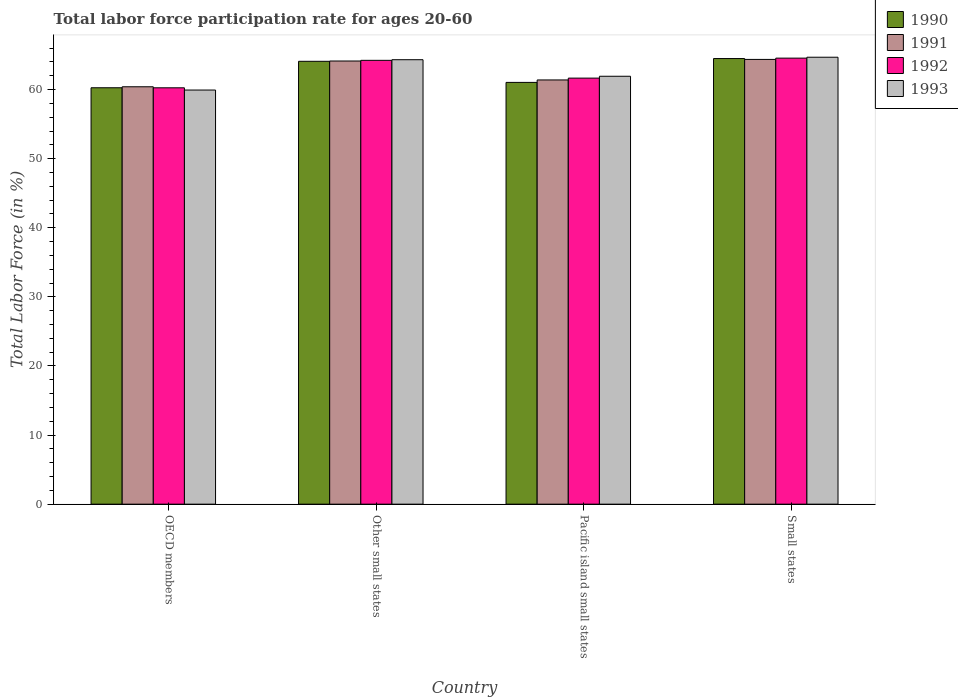How many different coloured bars are there?
Keep it short and to the point. 4. How many groups of bars are there?
Ensure brevity in your answer.  4. How many bars are there on the 4th tick from the left?
Provide a short and direct response. 4. In how many cases, is the number of bars for a given country not equal to the number of legend labels?
Give a very brief answer. 0. What is the labor force participation rate in 1992 in Pacific island small states?
Give a very brief answer. 61.67. Across all countries, what is the maximum labor force participation rate in 1990?
Provide a succinct answer. 64.5. Across all countries, what is the minimum labor force participation rate in 1993?
Make the answer very short. 59.94. In which country was the labor force participation rate in 1992 maximum?
Keep it short and to the point. Small states. What is the total labor force participation rate in 1992 in the graph?
Offer a very short reply. 250.73. What is the difference between the labor force participation rate in 1990 in OECD members and that in Other small states?
Give a very brief answer. -3.83. What is the difference between the labor force participation rate in 1993 in Pacific island small states and the labor force participation rate in 1990 in OECD members?
Make the answer very short. 1.67. What is the average labor force participation rate in 1990 per country?
Your answer should be compact. 62.48. What is the difference between the labor force participation rate of/in 1991 and labor force participation rate of/in 1993 in Small states?
Your answer should be compact. -0.32. In how many countries, is the labor force participation rate in 1990 greater than 64 %?
Give a very brief answer. 2. What is the ratio of the labor force participation rate in 1991 in OECD members to that in Pacific island small states?
Make the answer very short. 0.98. Is the labor force participation rate in 1993 in Other small states less than that in Small states?
Provide a succinct answer. Yes. What is the difference between the highest and the second highest labor force participation rate in 1991?
Offer a very short reply. 0.23. What is the difference between the highest and the lowest labor force participation rate in 1993?
Your answer should be compact. 4.75. In how many countries, is the labor force participation rate in 1990 greater than the average labor force participation rate in 1990 taken over all countries?
Offer a very short reply. 2. Is it the case that in every country, the sum of the labor force participation rate in 1993 and labor force participation rate in 1990 is greater than the sum of labor force participation rate in 1992 and labor force participation rate in 1991?
Offer a very short reply. No. What does the 2nd bar from the left in OECD members represents?
Provide a succinct answer. 1991. What does the 2nd bar from the right in OECD members represents?
Offer a very short reply. 1992. How many countries are there in the graph?
Make the answer very short. 4. What is the difference between two consecutive major ticks on the Y-axis?
Offer a terse response. 10. Does the graph contain any zero values?
Your answer should be compact. No. Where does the legend appear in the graph?
Your response must be concise. Top right. How are the legend labels stacked?
Make the answer very short. Vertical. What is the title of the graph?
Your answer should be compact. Total labor force participation rate for ages 20-60. What is the label or title of the X-axis?
Offer a very short reply. Country. What is the Total Labor Force (in %) of 1990 in OECD members?
Offer a very short reply. 60.27. What is the Total Labor Force (in %) in 1991 in OECD members?
Provide a succinct answer. 60.41. What is the Total Labor Force (in %) of 1992 in OECD members?
Keep it short and to the point. 60.26. What is the Total Labor Force (in %) of 1993 in OECD members?
Give a very brief answer. 59.94. What is the Total Labor Force (in %) of 1990 in Other small states?
Provide a short and direct response. 64.1. What is the Total Labor Force (in %) of 1991 in Other small states?
Provide a short and direct response. 64.14. What is the Total Labor Force (in %) in 1992 in Other small states?
Provide a short and direct response. 64.24. What is the Total Labor Force (in %) in 1993 in Other small states?
Provide a succinct answer. 64.33. What is the Total Labor Force (in %) of 1990 in Pacific island small states?
Offer a terse response. 61.05. What is the Total Labor Force (in %) of 1991 in Pacific island small states?
Your response must be concise. 61.4. What is the Total Labor Force (in %) of 1992 in Pacific island small states?
Offer a very short reply. 61.67. What is the Total Labor Force (in %) of 1993 in Pacific island small states?
Your answer should be compact. 61.94. What is the Total Labor Force (in %) of 1990 in Small states?
Ensure brevity in your answer.  64.5. What is the Total Labor Force (in %) of 1991 in Small states?
Your response must be concise. 64.37. What is the Total Labor Force (in %) of 1992 in Small states?
Ensure brevity in your answer.  64.56. What is the Total Labor Force (in %) in 1993 in Small states?
Offer a very short reply. 64.69. Across all countries, what is the maximum Total Labor Force (in %) in 1990?
Provide a short and direct response. 64.5. Across all countries, what is the maximum Total Labor Force (in %) of 1991?
Offer a terse response. 64.37. Across all countries, what is the maximum Total Labor Force (in %) in 1992?
Offer a very short reply. 64.56. Across all countries, what is the maximum Total Labor Force (in %) in 1993?
Provide a short and direct response. 64.69. Across all countries, what is the minimum Total Labor Force (in %) in 1990?
Offer a very short reply. 60.27. Across all countries, what is the minimum Total Labor Force (in %) in 1991?
Make the answer very short. 60.41. Across all countries, what is the minimum Total Labor Force (in %) in 1992?
Give a very brief answer. 60.26. Across all countries, what is the minimum Total Labor Force (in %) of 1993?
Provide a succinct answer. 59.94. What is the total Total Labor Force (in %) of 1990 in the graph?
Your answer should be very brief. 249.92. What is the total Total Labor Force (in %) in 1991 in the graph?
Your answer should be very brief. 250.33. What is the total Total Labor Force (in %) in 1992 in the graph?
Keep it short and to the point. 250.73. What is the total Total Labor Force (in %) of 1993 in the graph?
Provide a succinct answer. 250.9. What is the difference between the Total Labor Force (in %) in 1990 in OECD members and that in Other small states?
Your answer should be very brief. -3.83. What is the difference between the Total Labor Force (in %) of 1991 in OECD members and that in Other small states?
Make the answer very short. -3.73. What is the difference between the Total Labor Force (in %) in 1992 in OECD members and that in Other small states?
Make the answer very short. -3.98. What is the difference between the Total Labor Force (in %) of 1993 in OECD members and that in Other small states?
Provide a succinct answer. -4.39. What is the difference between the Total Labor Force (in %) of 1990 in OECD members and that in Pacific island small states?
Your response must be concise. -0.78. What is the difference between the Total Labor Force (in %) of 1991 in OECD members and that in Pacific island small states?
Keep it short and to the point. -0.99. What is the difference between the Total Labor Force (in %) of 1992 in OECD members and that in Pacific island small states?
Provide a short and direct response. -1.4. What is the difference between the Total Labor Force (in %) in 1993 in OECD members and that in Pacific island small states?
Keep it short and to the point. -2. What is the difference between the Total Labor Force (in %) of 1990 in OECD members and that in Small states?
Give a very brief answer. -4.23. What is the difference between the Total Labor Force (in %) in 1991 in OECD members and that in Small states?
Your answer should be compact. -3.96. What is the difference between the Total Labor Force (in %) in 1992 in OECD members and that in Small states?
Your response must be concise. -4.3. What is the difference between the Total Labor Force (in %) of 1993 in OECD members and that in Small states?
Offer a terse response. -4.75. What is the difference between the Total Labor Force (in %) in 1990 in Other small states and that in Pacific island small states?
Ensure brevity in your answer.  3.05. What is the difference between the Total Labor Force (in %) of 1991 in Other small states and that in Pacific island small states?
Keep it short and to the point. 2.74. What is the difference between the Total Labor Force (in %) of 1992 in Other small states and that in Pacific island small states?
Keep it short and to the point. 2.57. What is the difference between the Total Labor Force (in %) of 1993 in Other small states and that in Pacific island small states?
Your response must be concise. 2.4. What is the difference between the Total Labor Force (in %) of 1990 in Other small states and that in Small states?
Your answer should be very brief. -0.4. What is the difference between the Total Labor Force (in %) in 1991 in Other small states and that in Small states?
Offer a terse response. -0.23. What is the difference between the Total Labor Force (in %) of 1992 in Other small states and that in Small states?
Provide a short and direct response. -0.32. What is the difference between the Total Labor Force (in %) in 1993 in Other small states and that in Small states?
Ensure brevity in your answer.  -0.36. What is the difference between the Total Labor Force (in %) of 1990 in Pacific island small states and that in Small states?
Ensure brevity in your answer.  -3.45. What is the difference between the Total Labor Force (in %) in 1991 in Pacific island small states and that in Small states?
Provide a short and direct response. -2.97. What is the difference between the Total Labor Force (in %) of 1992 in Pacific island small states and that in Small states?
Give a very brief answer. -2.89. What is the difference between the Total Labor Force (in %) of 1993 in Pacific island small states and that in Small states?
Offer a terse response. -2.75. What is the difference between the Total Labor Force (in %) in 1990 in OECD members and the Total Labor Force (in %) in 1991 in Other small states?
Your response must be concise. -3.87. What is the difference between the Total Labor Force (in %) in 1990 in OECD members and the Total Labor Force (in %) in 1992 in Other small states?
Your response must be concise. -3.97. What is the difference between the Total Labor Force (in %) of 1990 in OECD members and the Total Labor Force (in %) of 1993 in Other small states?
Give a very brief answer. -4.06. What is the difference between the Total Labor Force (in %) in 1991 in OECD members and the Total Labor Force (in %) in 1992 in Other small states?
Offer a very short reply. -3.83. What is the difference between the Total Labor Force (in %) of 1991 in OECD members and the Total Labor Force (in %) of 1993 in Other small states?
Make the answer very short. -3.92. What is the difference between the Total Labor Force (in %) in 1992 in OECD members and the Total Labor Force (in %) in 1993 in Other small states?
Keep it short and to the point. -4.07. What is the difference between the Total Labor Force (in %) of 1990 in OECD members and the Total Labor Force (in %) of 1991 in Pacific island small states?
Offer a terse response. -1.13. What is the difference between the Total Labor Force (in %) in 1990 in OECD members and the Total Labor Force (in %) in 1992 in Pacific island small states?
Ensure brevity in your answer.  -1.4. What is the difference between the Total Labor Force (in %) in 1990 in OECD members and the Total Labor Force (in %) in 1993 in Pacific island small states?
Provide a succinct answer. -1.67. What is the difference between the Total Labor Force (in %) of 1991 in OECD members and the Total Labor Force (in %) of 1992 in Pacific island small states?
Offer a very short reply. -1.25. What is the difference between the Total Labor Force (in %) of 1991 in OECD members and the Total Labor Force (in %) of 1993 in Pacific island small states?
Provide a succinct answer. -1.52. What is the difference between the Total Labor Force (in %) of 1992 in OECD members and the Total Labor Force (in %) of 1993 in Pacific island small states?
Make the answer very short. -1.67. What is the difference between the Total Labor Force (in %) in 1990 in OECD members and the Total Labor Force (in %) in 1991 in Small states?
Your response must be concise. -4.1. What is the difference between the Total Labor Force (in %) in 1990 in OECD members and the Total Labor Force (in %) in 1992 in Small states?
Your answer should be very brief. -4.29. What is the difference between the Total Labor Force (in %) of 1990 in OECD members and the Total Labor Force (in %) of 1993 in Small states?
Ensure brevity in your answer.  -4.42. What is the difference between the Total Labor Force (in %) of 1991 in OECD members and the Total Labor Force (in %) of 1992 in Small states?
Your response must be concise. -4.15. What is the difference between the Total Labor Force (in %) of 1991 in OECD members and the Total Labor Force (in %) of 1993 in Small states?
Offer a very short reply. -4.28. What is the difference between the Total Labor Force (in %) of 1992 in OECD members and the Total Labor Force (in %) of 1993 in Small states?
Offer a very short reply. -4.43. What is the difference between the Total Labor Force (in %) in 1990 in Other small states and the Total Labor Force (in %) in 1991 in Pacific island small states?
Ensure brevity in your answer.  2.7. What is the difference between the Total Labor Force (in %) in 1990 in Other small states and the Total Labor Force (in %) in 1992 in Pacific island small states?
Your answer should be compact. 2.43. What is the difference between the Total Labor Force (in %) in 1990 in Other small states and the Total Labor Force (in %) in 1993 in Pacific island small states?
Make the answer very short. 2.16. What is the difference between the Total Labor Force (in %) of 1991 in Other small states and the Total Labor Force (in %) of 1992 in Pacific island small states?
Your answer should be compact. 2.48. What is the difference between the Total Labor Force (in %) of 1991 in Other small states and the Total Labor Force (in %) of 1993 in Pacific island small states?
Make the answer very short. 2.21. What is the difference between the Total Labor Force (in %) in 1992 in Other small states and the Total Labor Force (in %) in 1993 in Pacific island small states?
Offer a very short reply. 2.3. What is the difference between the Total Labor Force (in %) of 1990 in Other small states and the Total Labor Force (in %) of 1991 in Small states?
Provide a succinct answer. -0.27. What is the difference between the Total Labor Force (in %) in 1990 in Other small states and the Total Labor Force (in %) in 1992 in Small states?
Make the answer very short. -0.46. What is the difference between the Total Labor Force (in %) of 1990 in Other small states and the Total Labor Force (in %) of 1993 in Small states?
Offer a terse response. -0.59. What is the difference between the Total Labor Force (in %) of 1991 in Other small states and the Total Labor Force (in %) of 1992 in Small states?
Your answer should be compact. -0.42. What is the difference between the Total Labor Force (in %) of 1991 in Other small states and the Total Labor Force (in %) of 1993 in Small states?
Offer a terse response. -0.55. What is the difference between the Total Labor Force (in %) in 1992 in Other small states and the Total Labor Force (in %) in 1993 in Small states?
Keep it short and to the point. -0.45. What is the difference between the Total Labor Force (in %) in 1990 in Pacific island small states and the Total Labor Force (in %) in 1991 in Small states?
Keep it short and to the point. -3.33. What is the difference between the Total Labor Force (in %) in 1990 in Pacific island small states and the Total Labor Force (in %) in 1992 in Small states?
Give a very brief answer. -3.51. What is the difference between the Total Labor Force (in %) of 1990 in Pacific island small states and the Total Labor Force (in %) of 1993 in Small states?
Give a very brief answer. -3.65. What is the difference between the Total Labor Force (in %) in 1991 in Pacific island small states and the Total Labor Force (in %) in 1992 in Small states?
Ensure brevity in your answer.  -3.16. What is the difference between the Total Labor Force (in %) of 1991 in Pacific island small states and the Total Labor Force (in %) of 1993 in Small states?
Provide a short and direct response. -3.29. What is the difference between the Total Labor Force (in %) in 1992 in Pacific island small states and the Total Labor Force (in %) in 1993 in Small states?
Your answer should be very brief. -3.02. What is the average Total Labor Force (in %) of 1990 per country?
Provide a short and direct response. 62.48. What is the average Total Labor Force (in %) of 1991 per country?
Ensure brevity in your answer.  62.58. What is the average Total Labor Force (in %) in 1992 per country?
Offer a terse response. 62.68. What is the average Total Labor Force (in %) of 1993 per country?
Make the answer very short. 62.72. What is the difference between the Total Labor Force (in %) in 1990 and Total Labor Force (in %) in 1991 in OECD members?
Keep it short and to the point. -0.14. What is the difference between the Total Labor Force (in %) in 1990 and Total Labor Force (in %) in 1992 in OECD members?
Your response must be concise. 0.01. What is the difference between the Total Labor Force (in %) of 1990 and Total Labor Force (in %) of 1993 in OECD members?
Offer a terse response. 0.33. What is the difference between the Total Labor Force (in %) of 1991 and Total Labor Force (in %) of 1992 in OECD members?
Keep it short and to the point. 0.15. What is the difference between the Total Labor Force (in %) of 1991 and Total Labor Force (in %) of 1993 in OECD members?
Your answer should be very brief. 0.47. What is the difference between the Total Labor Force (in %) in 1992 and Total Labor Force (in %) in 1993 in OECD members?
Provide a succinct answer. 0.32. What is the difference between the Total Labor Force (in %) of 1990 and Total Labor Force (in %) of 1991 in Other small states?
Provide a succinct answer. -0.04. What is the difference between the Total Labor Force (in %) of 1990 and Total Labor Force (in %) of 1992 in Other small states?
Provide a short and direct response. -0.14. What is the difference between the Total Labor Force (in %) in 1990 and Total Labor Force (in %) in 1993 in Other small states?
Your response must be concise. -0.23. What is the difference between the Total Labor Force (in %) in 1991 and Total Labor Force (in %) in 1992 in Other small states?
Ensure brevity in your answer.  -0.1. What is the difference between the Total Labor Force (in %) in 1991 and Total Labor Force (in %) in 1993 in Other small states?
Provide a short and direct response. -0.19. What is the difference between the Total Labor Force (in %) of 1992 and Total Labor Force (in %) of 1993 in Other small states?
Keep it short and to the point. -0.09. What is the difference between the Total Labor Force (in %) in 1990 and Total Labor Force (in %) in 1991 in Pacific island small states?
Keep it short and to the point. -0.36. What is the difference between the Total Labor Force (in %) in 1990 and Total Labor Force (in %) in 1992 in Pacific island small states?
Your answer should be very brief. -0.62. What is the difference between the Total Labor Force (in %) of 1990 and Total Labor Force (in %) of 1993 in Pacific island small states?
Make the answer very short. -0.89. What is the difference between the Total Labor Force (in %) in 1991 and Total Labor Force (in %) in 1992 in Pacific island small states?
Give a very brief answer. -0.27. What is the difference between the Total Labor Force (in %) of 1991 and Total Labor Force (in %) of 1993 in Pacific island small states?
Offer a very short reply. -0.53. What is the difference between the Total Labor Force (in %) in 1992 and Total Labor Force (in %) in 1993 in Pacific island small states?
Provide a succinct answer. -0.27. What is the difference between the Total Labor Force (in %) in 1990 and Total Labor Force (in %) in 1991 in Small states?
Your answer should be very brief. 0.12. What is the difference between the Total Labor Force (in %) in 1990 and Total Labor Force (in %) in 1992 in Small states?
Offer a terse response. -0.06. What is the difference between the Total Labor Force (in %) of 1990 and Total Labor Force (in %) of 1993 in Small states?
Provide a succinct answer. -0.19. What is the difference between the Total Labor Force (in %) of 1991 and Total Labor Force (in %) of 1992 in Small states?
Your answer should be compact. -0.19. What is the difference between the Total Labor Force (in %) in 1991 and Total Labor Force (in %) in 1993 in Small states?
Make the answer very short. -0.32. What is the difference between the Total Labor Force (in %) in 1992 and Total Labor Force (in %) in 1993 in Small states?
Your answer should be compact. -0.13. What is the ratio of the Total Labor Force (in %) of 1990 in OECD members to that in Other small states?
Your response must be concise. 0.94. What is the ratio of the Total Labor Force (in %) in 1991 in OECD members to that in Other small states?
Provide a short and direct response. 0.94. What is the ratio of the Total Labor Force (in %) of 1992 in OECD members to that in Other small states?
Your response must be concise. 0.94. What is the ratio of the Total Labor Force (in %) of 1993 in OECD members to that in Other small states?
Offer a very short reply. 0.93. What is the ratio of the Total Labor Force (in %) of 1990 in OECD members to that in Pacific island small states?
Give a very brief answer. 0.99. What is the ratio of the Total Labor Force (in %) of 1991 in OECD members to that in Pacific island small states?
Your answer should be very brief. 0.98. What is the ratio of the Total Labor Force (in %) in 1992 in OECD members to that in Pacific island small states?
Your answer should be very brief. 0.98. What is the ratio of the Total Labor Force (in %) of 1993 in OECD members to that in Pacific island small states?
Make the answer very short. 0.97. What is the ratio of the Total Labor Force (in %) of 1990 in OECD members to that in Small states?
Provide a succinct answer. 0.93. What is the ratio of the Total Labor Force (in %) of 1991 in OECD members to that in Small states?
Ensure brevity in your answer.  0.94. What is the ratio of the Total Labor Force (in %) of 1992 in OECD members to that in Small states?
Give a very brief answer. 0.93. What is the ratio of the Total Labor Force (in %) in 1993 in OECD members to that in Small states?
Your answer should be very brief. 0.93. What is the ratio of the Total Labor Force (in %) of 1990 in Other small states to that in Pacific island small states?
Offer a terse response. 1.05. What is the ratio of the Total Labor Force (in %) of 1991 in Other small states to that in Pacific island small states?
Offer a terse response. 1.04. What is the ratio of the Total Labor Force (in %) of 1992 in Other small states to that in Pacific island small states?
Offer a very short reply. 1.04. What is the ratio of the Total Labor Force (in %) of 1993 in Other small states to that in Pacific island small states?
Your answer should be compact. 1.04. What is the ratio of the Total Labor Force (in %) in 1990 in Other small states to that in Small states?
Your answer should be very brief. 0.99. What is the ratio of the Total Labor Force (in %) of 1990 in Pacific island small states to that in Small states?
Ensure brevity in your answer.  0.95. What is the ratio of the Total Labor Force (in %) in 1991 in Pacific island small states to that in Small states?
Give a very brief answer. 0.95. What is the ratio of the Total Labor Force (in %) of 1992 in Pacific island small states to that in Small states?
Make the answer very short. 0.96. What is the ratio of the Total Labor Force (in %) of 1993 in Pacific island small states to that in Small states?
Ensure brevity in your answer.  0.96. What is the difference between the highest and the second highest Total Labor Force (in %) of 1990?
Your response must be concise. 0.4. What is the difference between the highest and the second highest Total Labor Force (in %) of 1991?
Make the answer very short. 0.23. What is the difference between the highest and the second highest Total Labor Force (in %) of 1992?
Offer a terse response. 0.32. What is the difference between the highest and the second highest Total Labor Force (in %) in 1993?
Your response must be concise. 0.36. What is the difference between the highest and the lowest Total Labor Force (in %) in 1990?
Offer a terse response. 4.23. What is the difference between the highest and the lowest Total Labor Force (in %) in 1991?
Make the answer very short. 3.96. What is the difference between the highest and the lowest Total Labor Force (in %) in 1992?
Your response must be concise. 4.3. What is the difference between the highest and the lowest Total Labor Force (in %) in 1993?
Give a very brief answer. 4.75. 